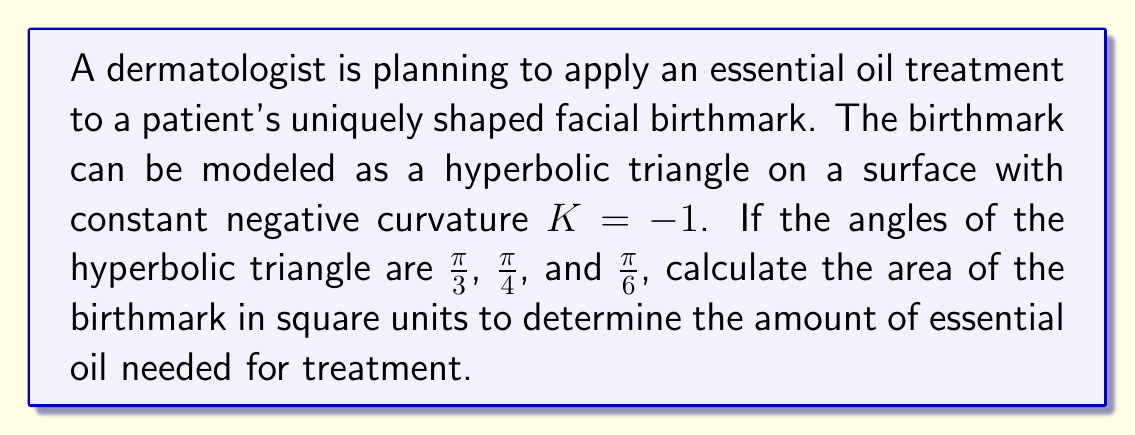Can you solve this math problem? To solve this problem, we'll use the Gauss-Bonnet formula for hyperbolic triangles:

1) The Gauss-Bonnet formula for a hyperbolic triangle states:
   $$A = -K(\alpha + \beta + \gamma - \pi)$$
   where $A$ is the area, $K$ is the curvature, and $\alpha$, $\beta$, and $\gamma$ are the angles of the triangle.

2) We're given that $K = -1$ and the angles are $\frac{\pi}{3}$, $\frac{\pi}{4}$, and $\frac{\pi}{6}$.

3) Substituting these values into the formula:
   $$A = -(-1)(\frac{\pi}{3} + \frac{\pi}{4} + \frac{\pi}{6} - \pi)$$

4) Simplify the expression inside the parentheses:
   $$A = \frac{\pi}{3} + \frac{\pi}{4} + \frac{\pi}{6} - \pi$$

5) Find a common denominator of 12:
   $$A = \frac{4\pi}{12} + \frac{3\pi}{12} + \frac{2\pi}{12} - \frac{12\pi}{12}$$

6) Add the fractions:
   $$A = \frac{9\pi}{12} - \frac{12\pi}{12} = -\frac{3\pi}{12} = -\frac{\pi}{4}$$

7) Therefore, the area of the hyperbolic triangle (birthmark) is $\frac{\pi}{4}$ square units.
Answer: $\frac{\pi}{4}$ square units 